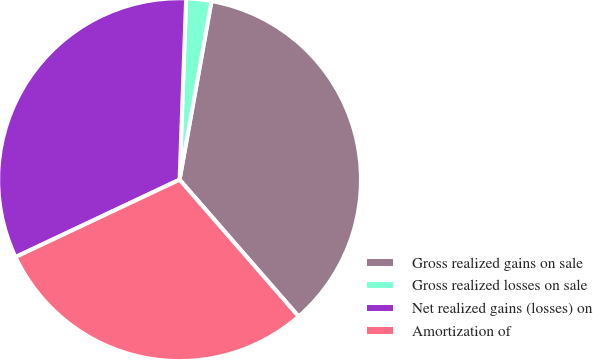Convert chart. <chart><loc_0><loc_0><loc_500><loc_500><pie_chart><fcel>Gross realized gains on sale<fcel>Gross realized losses on sale<fcel>Net realized gains (losses) on<fcel>Amortization of<nl><fcel>35.79%<fcel>2.24%<fcel>32.59%<fcel>29.38%<nl></chart> 